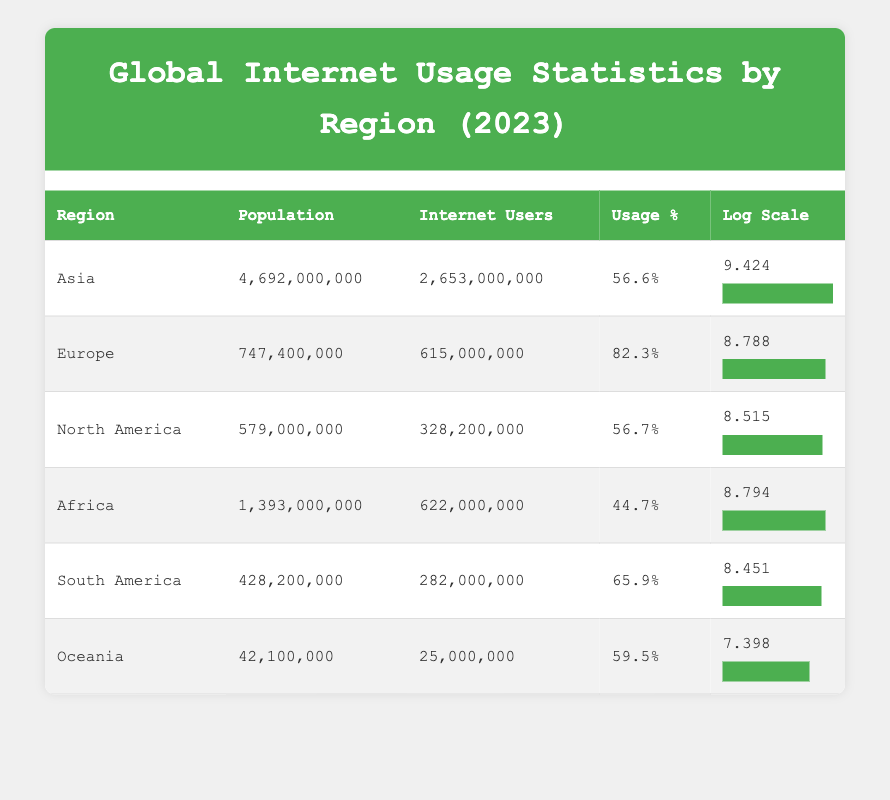What is the total population of Africa? The table lists Africa's population as 1,393,000,000. This is retrieved directly from the table under the Population column for Africa.
Answer: 1,393,000,000 Which region has the highest internet usage percentage? By comparing the Usage % column, Europe shows a percentage of 82.3%, which is higher than all other regions listed.
Answer: Europe What is the logarithmic value of internet users for South America? The table indicates that the Logarithmic Internet Users value for South America is 8.451, directly taken from the corresponding column.
Answer: 8.451 How many more internet users does Asia have compared to Africa? The Internet Users for Asia is 2,653,000,000 and for Africa, it is 622,000,000. Subtracting these gives 2,653,000,000 - 622,000,000 = 2,031,000,000 more internet users in Asia than in Africa.
Answer: 2,031,000,000 Is the internet usage percentage in Oceania greater than that in North America? Oceania has an internet usage percentage of 59.5%, while North America has 56.7%. Since 59.5% is greater than 56.7%, the statement is true.
Answer: Yes What is the average population of the regions listed in the table? To find the average, add all populations: 4,692,000,000 + 747,400,000 + 579,000,000 + 1,393,000,000 + 428,200,000 + 42,100,000 = 7,882,700,000. There are 6 regions, so dividing gives 7,882,700,000 / 6 = 1,313,783,333.33, rounding gives an average of approximately 1,313,783,333.
Answer: 1,313,783,333 Which two regions have the closest logarithmic values for internet users? Reviewing the Logarithmic Internet Users values, Africa has 8.794 and Europe has 8.788. The difference is minimal (only 0.006), indicating they are the closest.
Answer: Africa and Europe What is the total number of internet users across all regions? The total can be calculated by adding the Internet Users for each region: 2,653,000,000 + 615,000,000 + 328,200,000 + 622,000,000 + 282,000,000 + 25,000,000 = 4,525,200,000.
Answer: 4,525,200,000 Is the internet user percentage in South America less than 60%? South America has a usage percentage of 65.9%, which is greater than 60%, so this statement is false.
Answer: No 